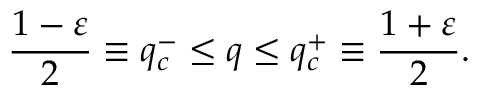Convert formula to latex. <formula><loc_0><loc_0><loc_500><loc_500>\frac { 1 - \varepsilon } { 2 } \equiv q _ { c } ^ { - } \leq q \leq q _ { c } ^ { + } \equiv \frac { 1 + \varepsilon } { 2 } .</formula> 